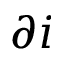Convert formula to latex. <formula><loc_0><loc_0><loc_500><loc_500>\partial i</formula> 